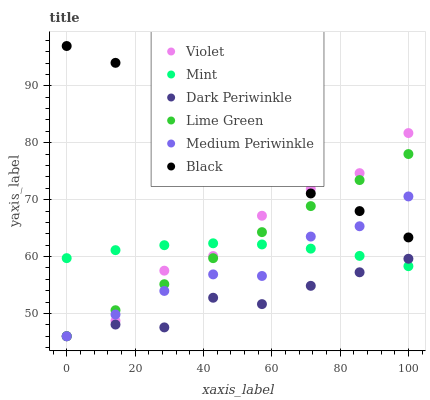Does Dark Periwinkle have the minimum area under the curve?
Answer yes or no. Yes. Does Black have the maximum area under the curve?
Answer yes or no. Yes. Does Medium Periwinkle have the minimum area under the curve?
Answer yes or no. No. Does Medium Periwinkle have the maximum area under the curve?
Answer yes or no. No. Is Lime Green the smoothest?
Answer yes or no. Yes. Is Violet the roughest?
Answer yes or no. Yes. Is Medium Periwinkle the smoothest?
Answer yes or no. No. Is Medium Periwinkle the roughest?
Answer yes or no. No. Does Medium Periwinkle have the lowest value?
Answer yes or no. Yes. Does Black have the lowest value?
Answer yes or no. No. Does Black have the highest value?
Answer yes or no. Yes. Does Medium Periwinkle have the highest value?
Answer yes or no. No. Is Dark Periwinkle less than Black?
Answer yes or no. Yes. Is Black greater than Dark Periwinkle?
Answer yes or no. Yes. Does Medium Periwinkle intersect Dark Periwinkle?
Answer yes or no. Yes. Is Medium Periwinkle less than Dark Periwinkle?
Answer yes or no. No. Is Medium Periwinkle greater than Dark Periwinkle?
Answer yes or no. No. Does Dark Periwinkle intersect Black?
Answer yes or no. No. 